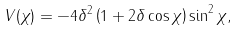<formula> <loc_0><loc_0><loc_500><loc_500>V ( \chi ) = - 4 \delta ^ { 2 } \left ( 1 + 2 \delta \cos \chi \right ) \sin ^ { 2 } \chi ,</formula> 